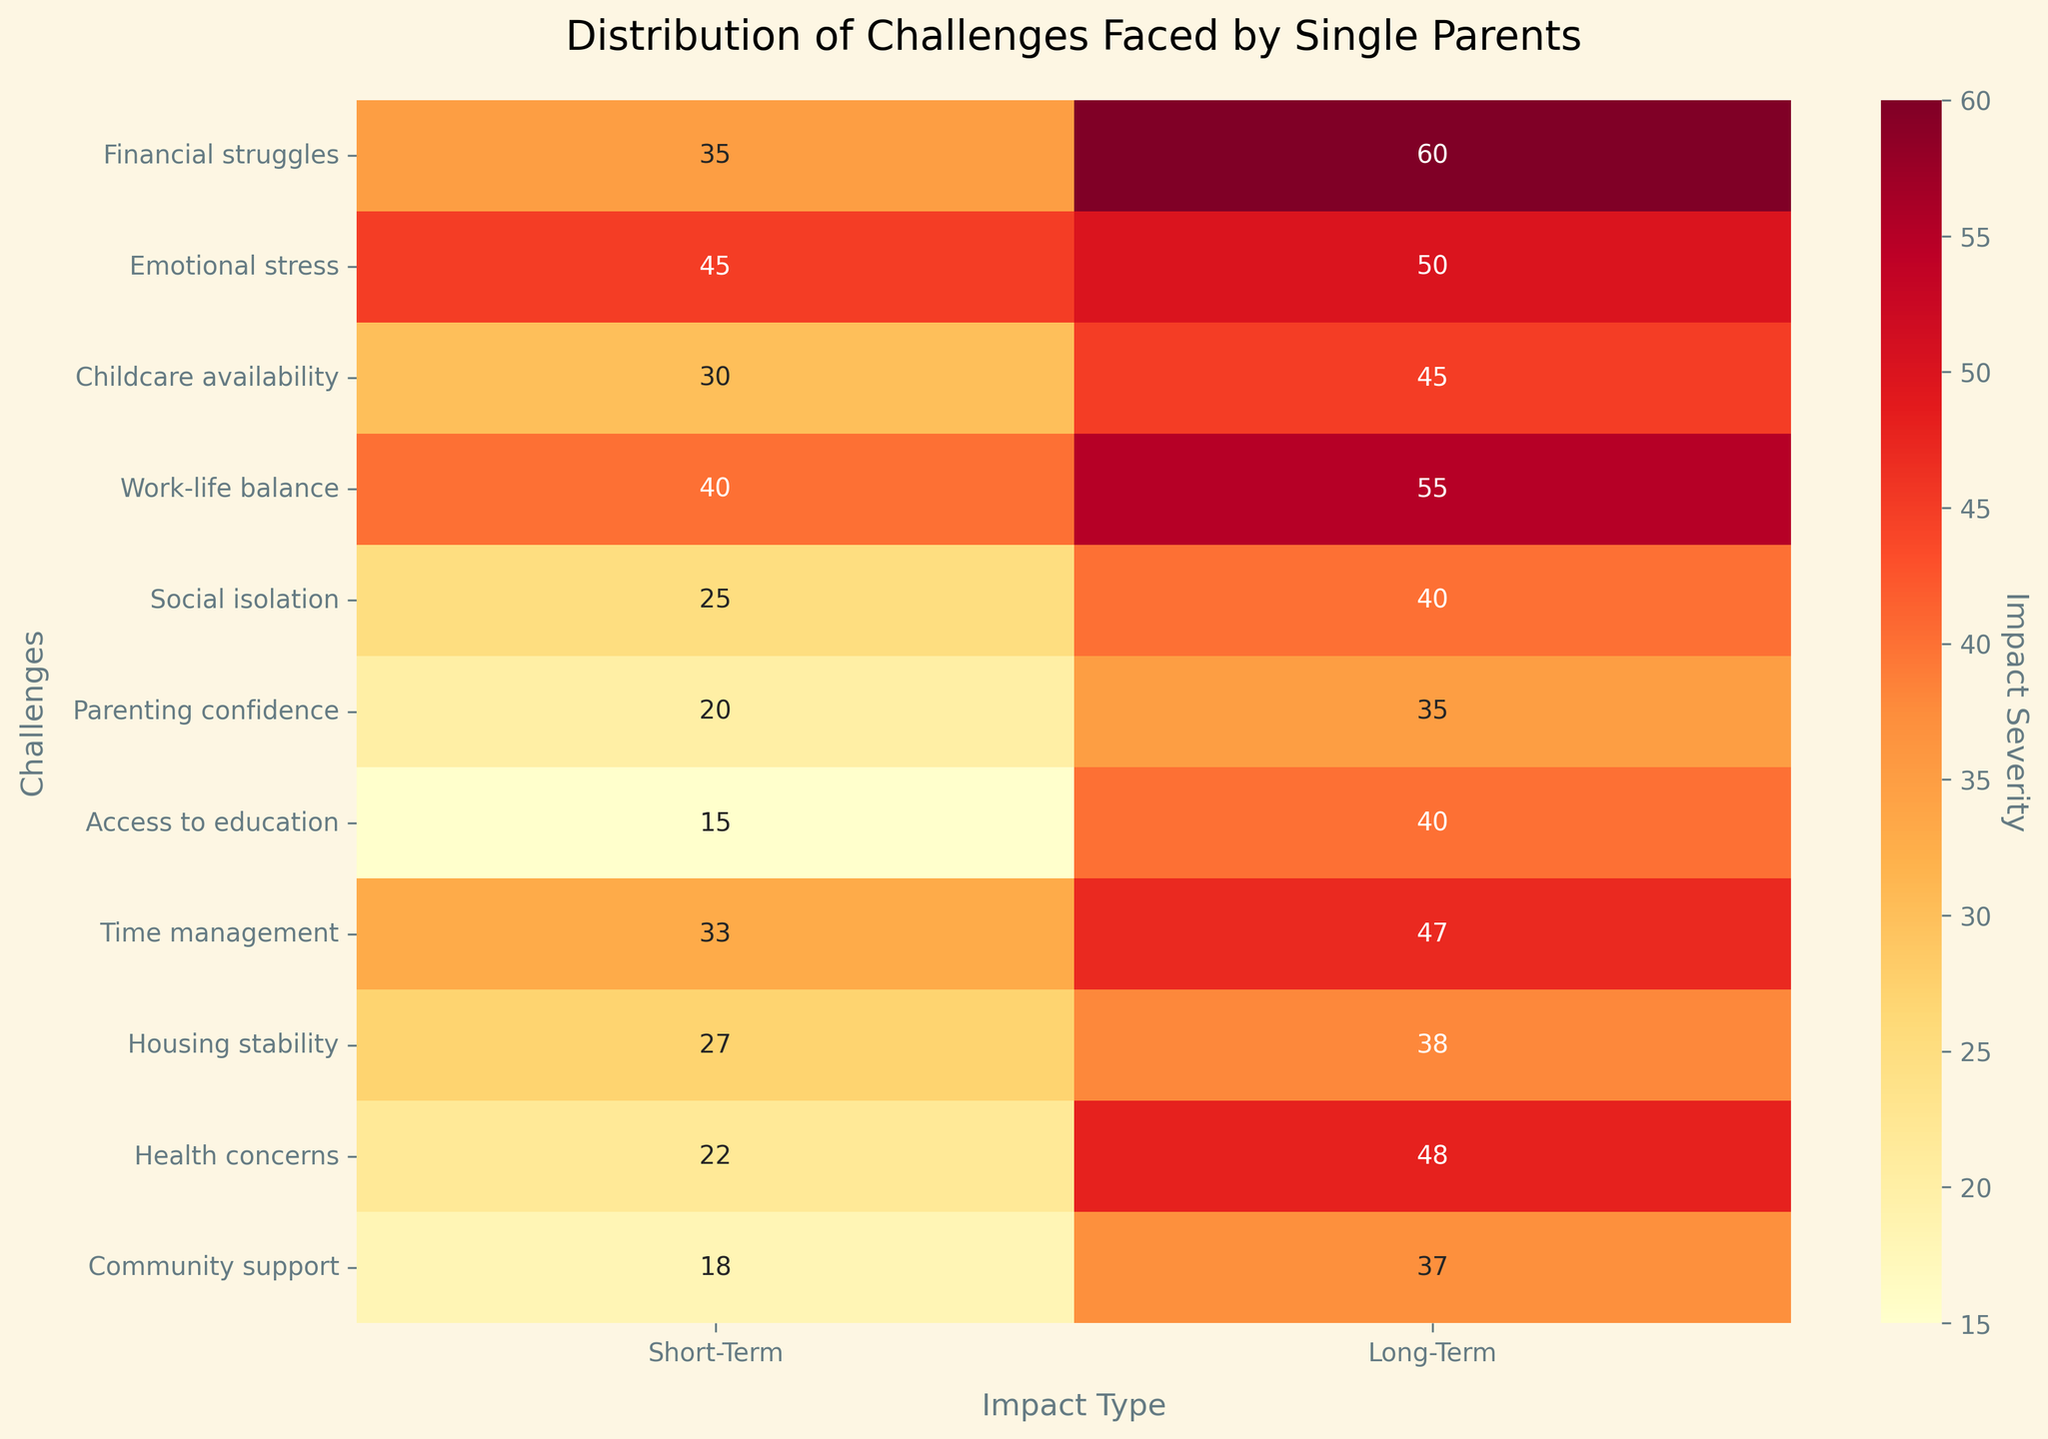What is the title of the plot? The title is usually located at the top of the plot, often in larger or bold font. By looking at the top of the figure, you can easily identify the title.
Answer: Distribution of Challenges Faced by Single Parents Which challenge has the highest short-term impact? To find the challenge with the highest short-term impact, look at the 'Short-Term' column of the heatmap and identify the highest value.
Answer: Emotional stress Which challenge has the lowest long-term impact? To find the challenge with the lowest long-term impact, look at the 'Long-Term' column of the heatmap and identify the lowest value.
Answer: Parenting confidence How does the short-term impact of 'Social isolation' compare to its long-term impact? Locate the 'Social isolation' row in the heatmap and compare the values in the 'Short-Term' and 'Long-Term' columns.
Answer: Short-term is 25, long-term is 40 What is the difference between the long-term and short-term impacts of 'Financial struggles'? Find the values for 'Financial struggles' in both columns. The short-term impact is 35, and the long-term impact is 60. Subtract the short-term value from the long-term value to calculate the difference, 60 - 35.
Answer: 25 What challenge has a greater short-term impact than 'Childcare availability' but a lower long-term impact than 'Work-life balance'? For short-term impacts, identify challenges with values greater than 30 ('Childcare availability'). For long-term impacts, look for values less than 55 ('Work-life balance'). Cross-reference to find the matching challenge.
Answer: Time management What is the average short-term impact of 'Childcare availability' and 'Housing stability'? Locate the short-term values for both challenges: 'Childcare availability' is 30 and 'Housing stability' is 27. Sum these values and divide by 2 to find the average, (30 + 27) / 2.
Answer: 28.5 Which challenge has a more significant long-term impact than 'Access to education' but a lesser short-term impact than 'Health concerns'? For long-term impacts, identify challenges with values greater than 40 ('Access to education'). For short-term impacts, look for values less than 22 ('Health concerns'). Cross-reference to find the matching challenge.
Answer: Parenting confidence 